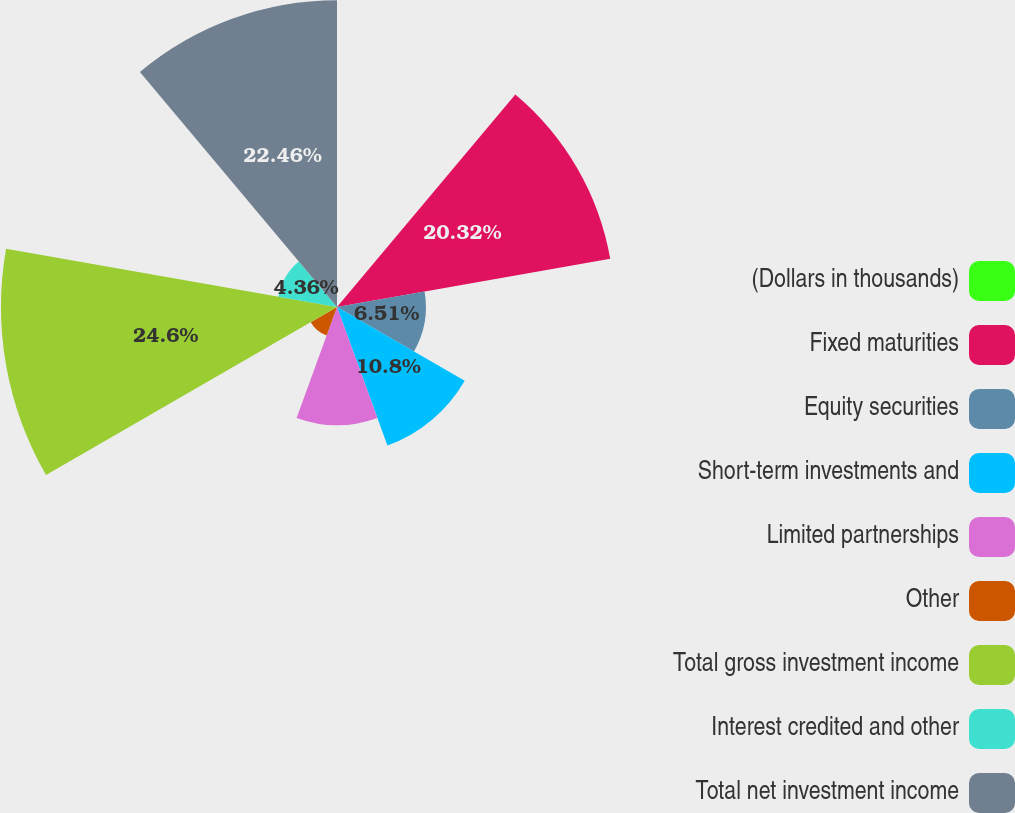Convert chart. <chart><loc_0><loc_0><loc_500><loc_500><pie_chart><fcel>(Dollars in thousands)<fcel>Fixed maturities<fcel>Equity securities<fcel>Short-term investments and<fcel>Limited partnerships<fcel>Other<fcel>Total gross investment income<fcel>Interest credited and other<fcel>Total net investment income<nl><fcel>0.08%<fcel>20.32%<fcel>6.51%<fcel>10.8%<fcel>8.65%<fcel>2.22%<fcel>24.61%<fcel>4.36%<fcel>22.46%<nl></chart> 